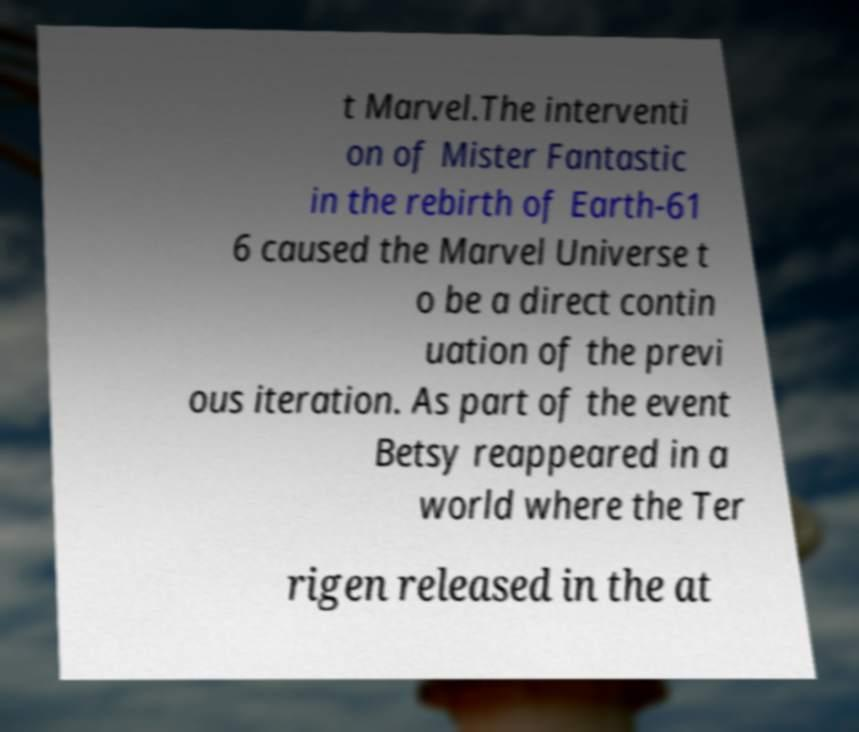What messages or text are displayed in this image? I need them in a readable, typed format. t Marvel.The interventi on of Mister Fantastic in the rebirth of Earth-61 6 caused the Marvel Universe t o be a direct contin uation of the previ ous iteration. As part of the event Betsy reappeared in a world where the Ter rigen released in the at 